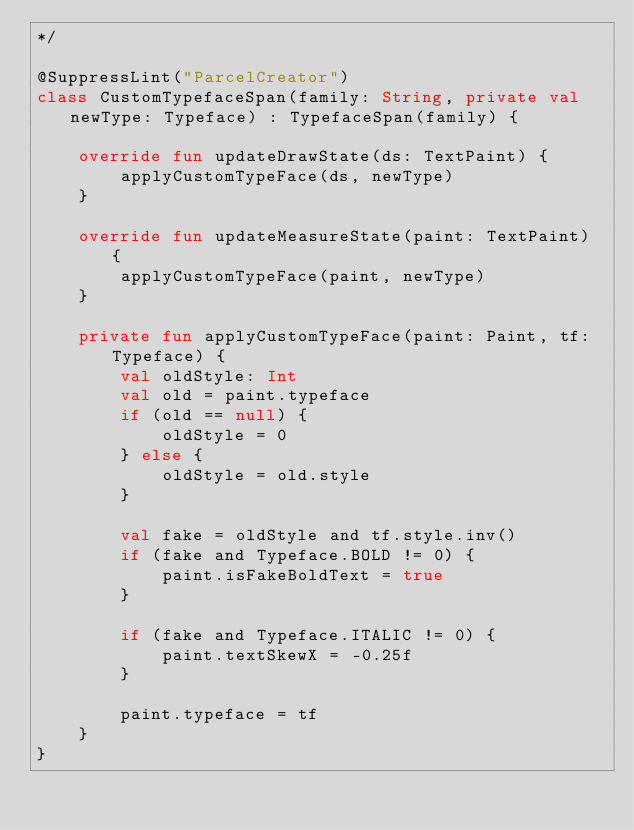<code> <loc_0><loc_0><loc_500><loc_500><_Kotlin_>*/

@SuppressLint("ParcelCreator")
class CustomTypefaceSpan(family: String, private val newType: Typeface) : TypefaceSpan(family) {

    override fun updateDrawState(ds: TextPaint) {
        applyCustomTypeFace(ds, newType)
    }

    override fun updateMeasureState(paint: TextPaint) {
        applyCustomTypeFace(paint, newType)
    }

    private fun applyCustomTypeFace(paint: Paint, tf: Typeface) {
        val oldStyle: Int
        val old = paint.typeface
        if (old == null) {
            oldStyle = 0
        } else {
            oldStyle = old.style
        }

        val fake = oldStyle and tf.style.inv()
        if (fake and Typeface.BOLD != 0) {
            paint.isFakeBoldText = true
        }

        if (fake and Typeface.ITALIC != 0) {
            paint.textSkewX = -0.25f
        }

        paint.typeface = tf
    }
}
</code> 